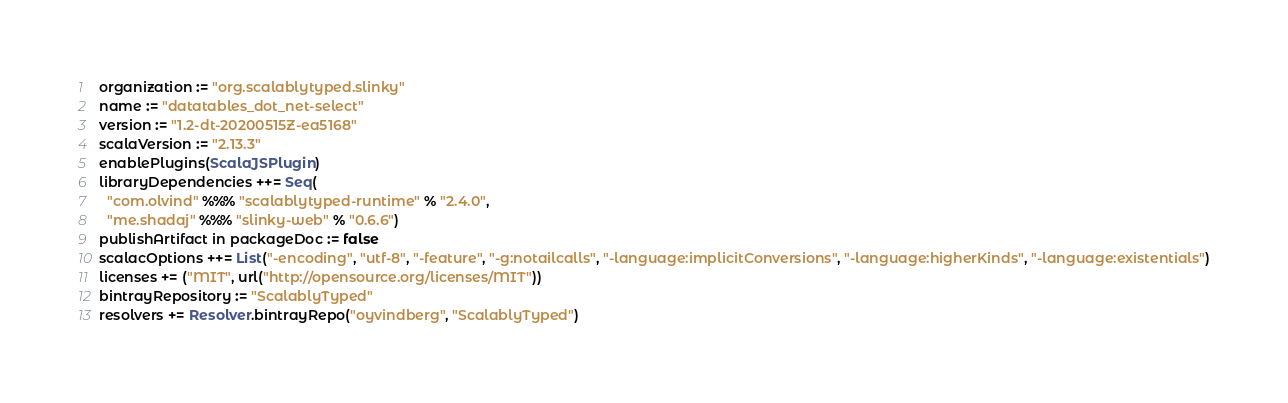<code> <loc_0><loc_0><loc_500><loc_500><_Scala_>organization := "org.scalablytyped.slinky"
name := "datatables_dot_net-select"
version := "1.2-dt-20200515Z-ea5168"
scalaVersion := "2.13.3"
enablePlugins(ScalaJSPlugin)
libraryDependencies ++= Seq(
  "com.olvind" %%% "scalablytyped-runtime" % "2.4.0",
  "me.shadaj" %%% "slinky-web" % "0.6.6")
publishArtifact in packageDoc := false
scalacOptions ++= List("-encoding", "utf-8", "-feature", "-g:notailcalls", "-language:implicitConversions", "-language:higherKinds", "-language:existentials")
licenses += ("MIT", url("http://opensource.org/licenses/MIT"))
bintrayRepository := "ScalablyTyped"
resolvers += Resolver.bintrayRepo("oyvindberg", "ScalablyTyped")
</code> 